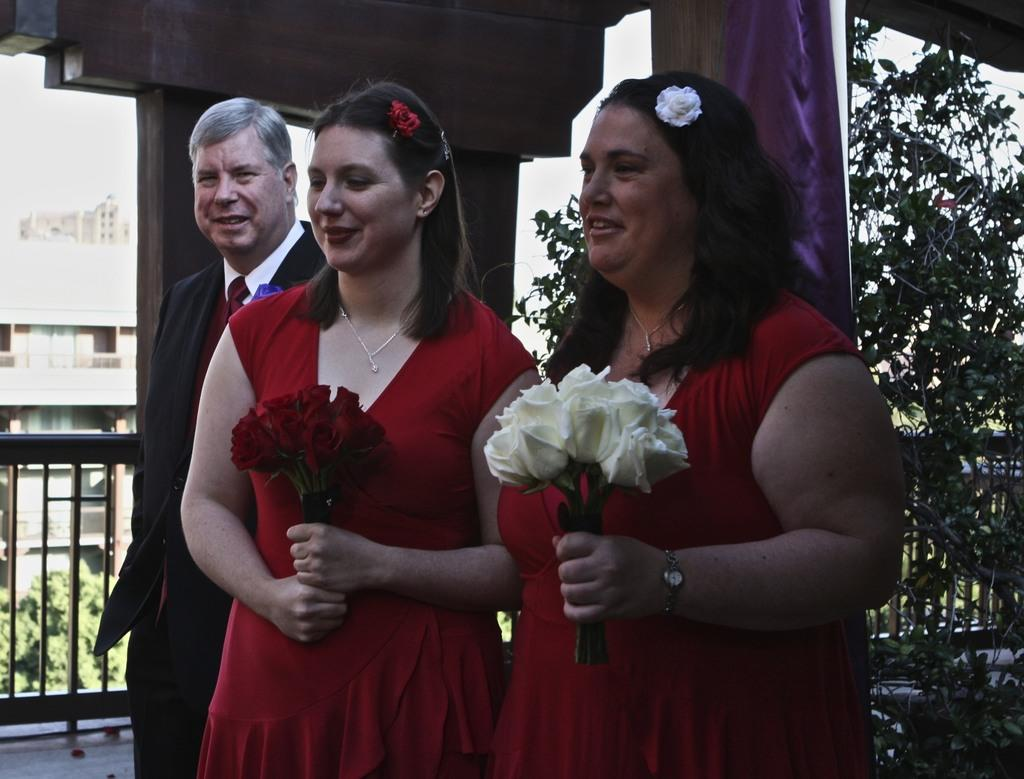How many people are in the image? There are people in the image, but the exact number is not specified. What are some people holding in the image? Some people are holding flowers in the image. What can be seen beneath the people's feet in the image? The ground is visible in the image. What type of barrier is present in the image? There is a fence in the image. What type of vegetation is present in the image? There are plants in the image. What type of man-made structures are present in the image? There are buildings in the image. What type of zipper can be seen on the plants in the image? There are no zippers present on the plants in the image. How quiet is the environment in the image? The provided facts do not give any information about the noise level in the image, so it cannot be determined. 